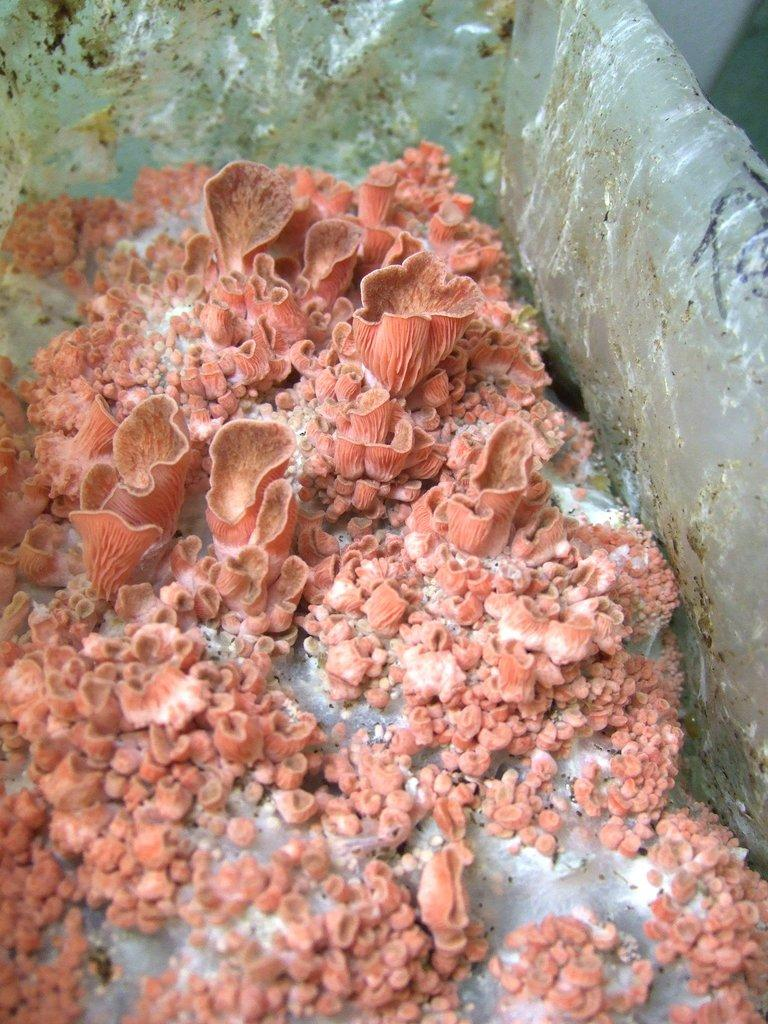What type of plant is visible in the image? There is a sea plant in the image. How is the sea plant being preserved or stored? The sea plant appears to be kept in ice. What type of crook can be seen in the image? There is no crook present in the image; it features a sea plant kept in ice. What nation is depicted in the image? The image does not depict a nation; it shows a sea plant being preserved in ice. 